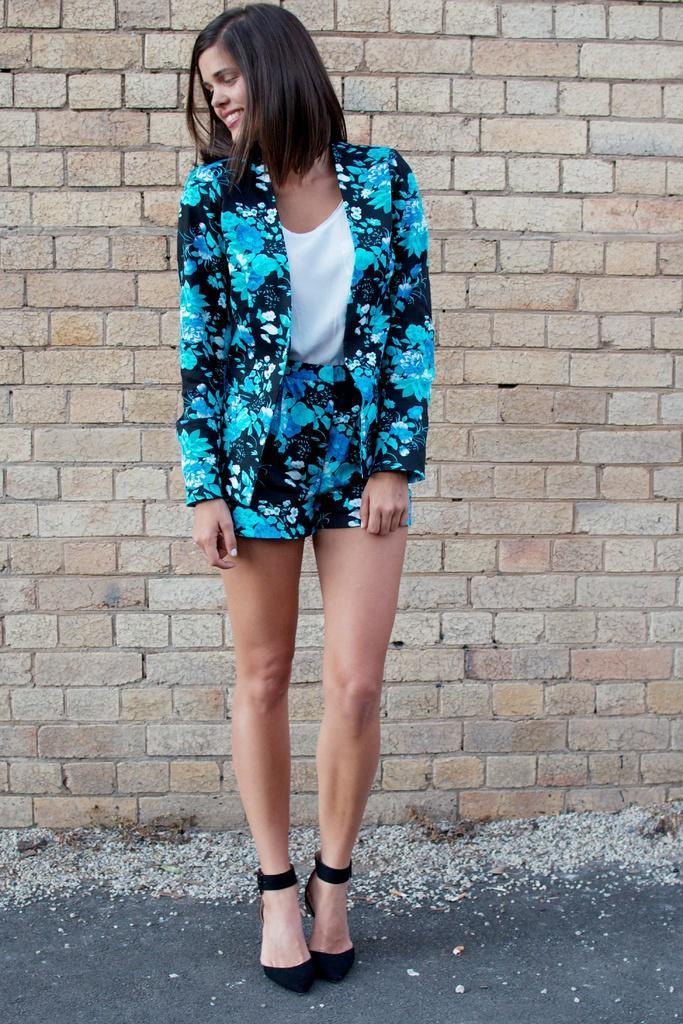Describe this image in one or two sentences. In this picture we can observe a woman standing and wearing blue and black color dress. She is standing on the road. In the background there is a wall which is in cream color. The woman is smiling. 